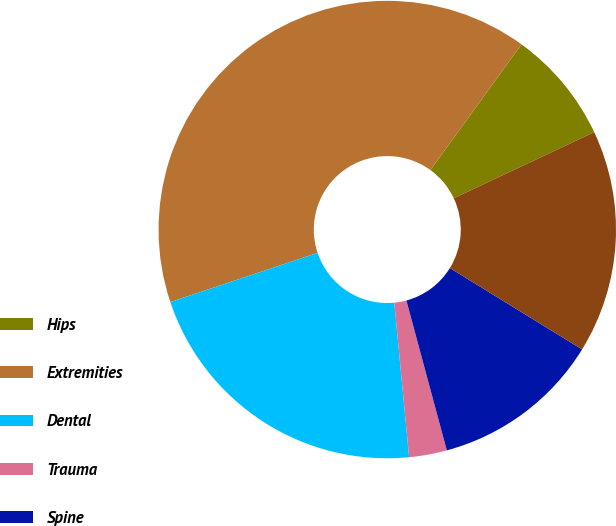<chart> <loc_0><loc_0><loc_500><loc_500><pie_chart><fcel>Hips<fcel>Extremities<fcel>Dental<fcel>Trauma<fcel>Spine<fcel>OSP and other<nl><fcel>8.02%<fcel>40.11%<fcel>21.39%<fcel>2.67%<fcel>12.03%<fcel>15.78%<nl></chart> 